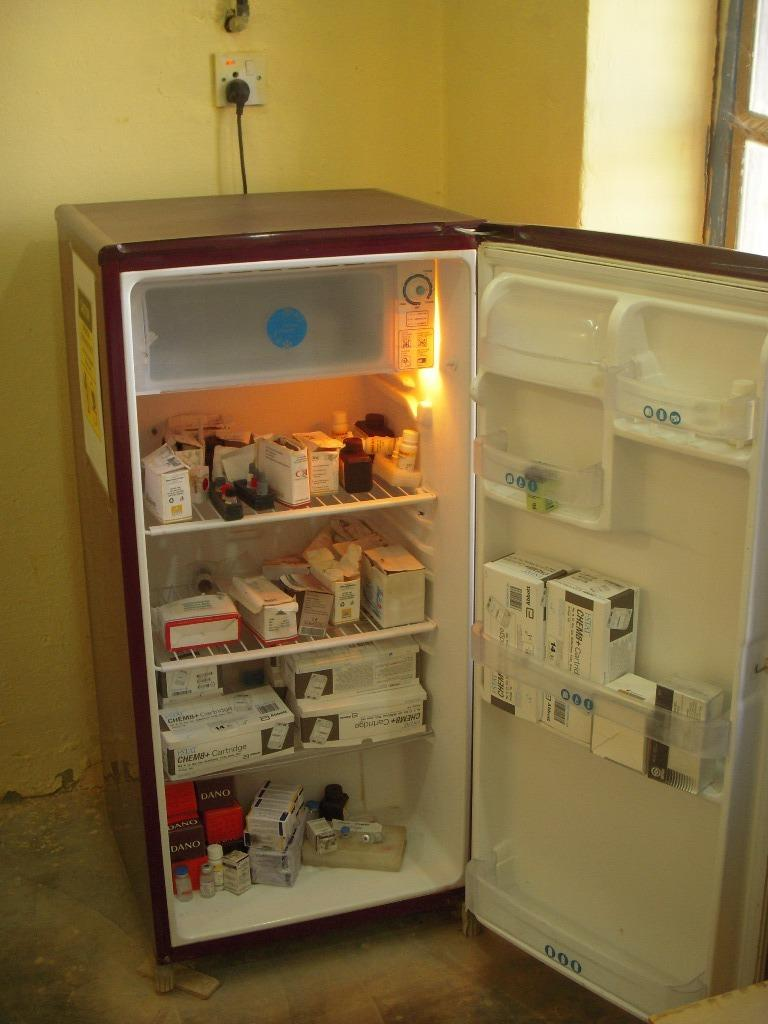What appliance can be seen in the image? There is a refrigerator in the image. What is stored inside the refrigerator? The refrigerator contains some medicine. What can be seen on the wall in the background of the image? There is a switch board on the wall in the background of the image. What is visible on the right side of the image? There is a window on the right side of the image. What type of beast can be seen interacting with the medicine in the image? There is no beast present in the image; it only contains a refrigerator with medicine inside. 